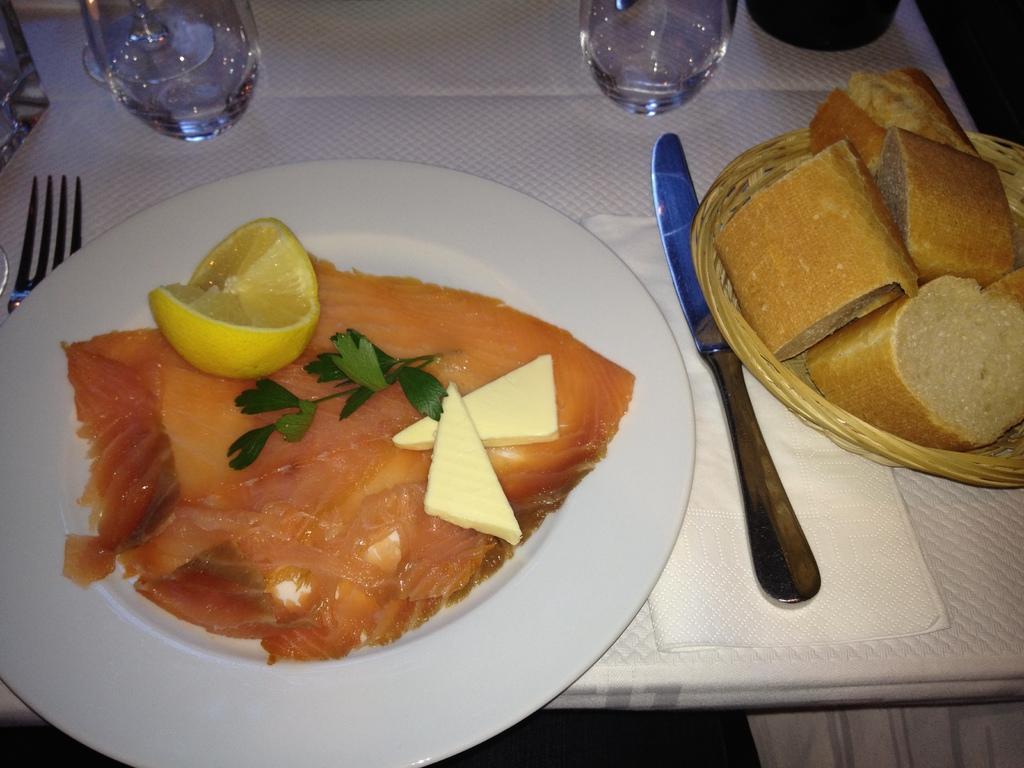How would you summarize this image in a sentence or two? In this image there is a table, on that table there is a plate, in that plate there is a food item, beside the plate there is a knife and fork and there are two glasses. 